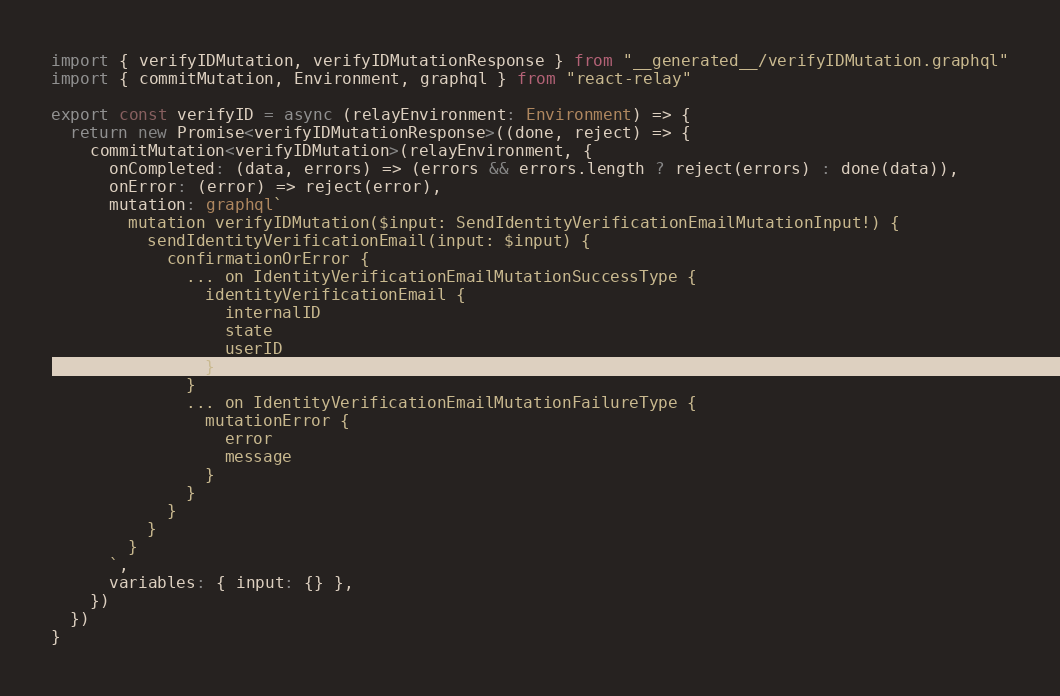<code> <loc_0><loc_0><loc_500><loc_500><_TypeScript_>import { verifyIDMutation, verifyIDMutationResponse } from "__generated__/verifyIDMutation.graphql"
import { commitMutation, Environment, graphql } from "react-relay"

export const verifyID = async (relayEnvironment: Environment) => {
  return new Promise<verifyIDMutationResponse>((done, reject) => {
    commitMutation<verifyIDMutation>(relayEnvironment, {
      onCompleted: (data, errors) => (errors && errors.length ? reject(errors) : done(data)),
      onError: (error) => reject(error),
      mutation: graphql`
        mutation verifyIDMutation($input: SendIdentityVerificationEmailMutationInput!) {
          sendIdentityVerificationEmail(input: $input) {
            confirmationOrError {
              ... on IdentityVerificationEmailMutationSuccessType {
                identityVerificationEmail {
                  internalID
                  state
                  userID
                }
              }
              ... on IdentityVerificationEmailMutationFailureType {
                mutationError {
                  error
                  message
                }
              }
            }
          }
        }
      `,
      variables: { input: {} },
    })
  })
}
</code> 